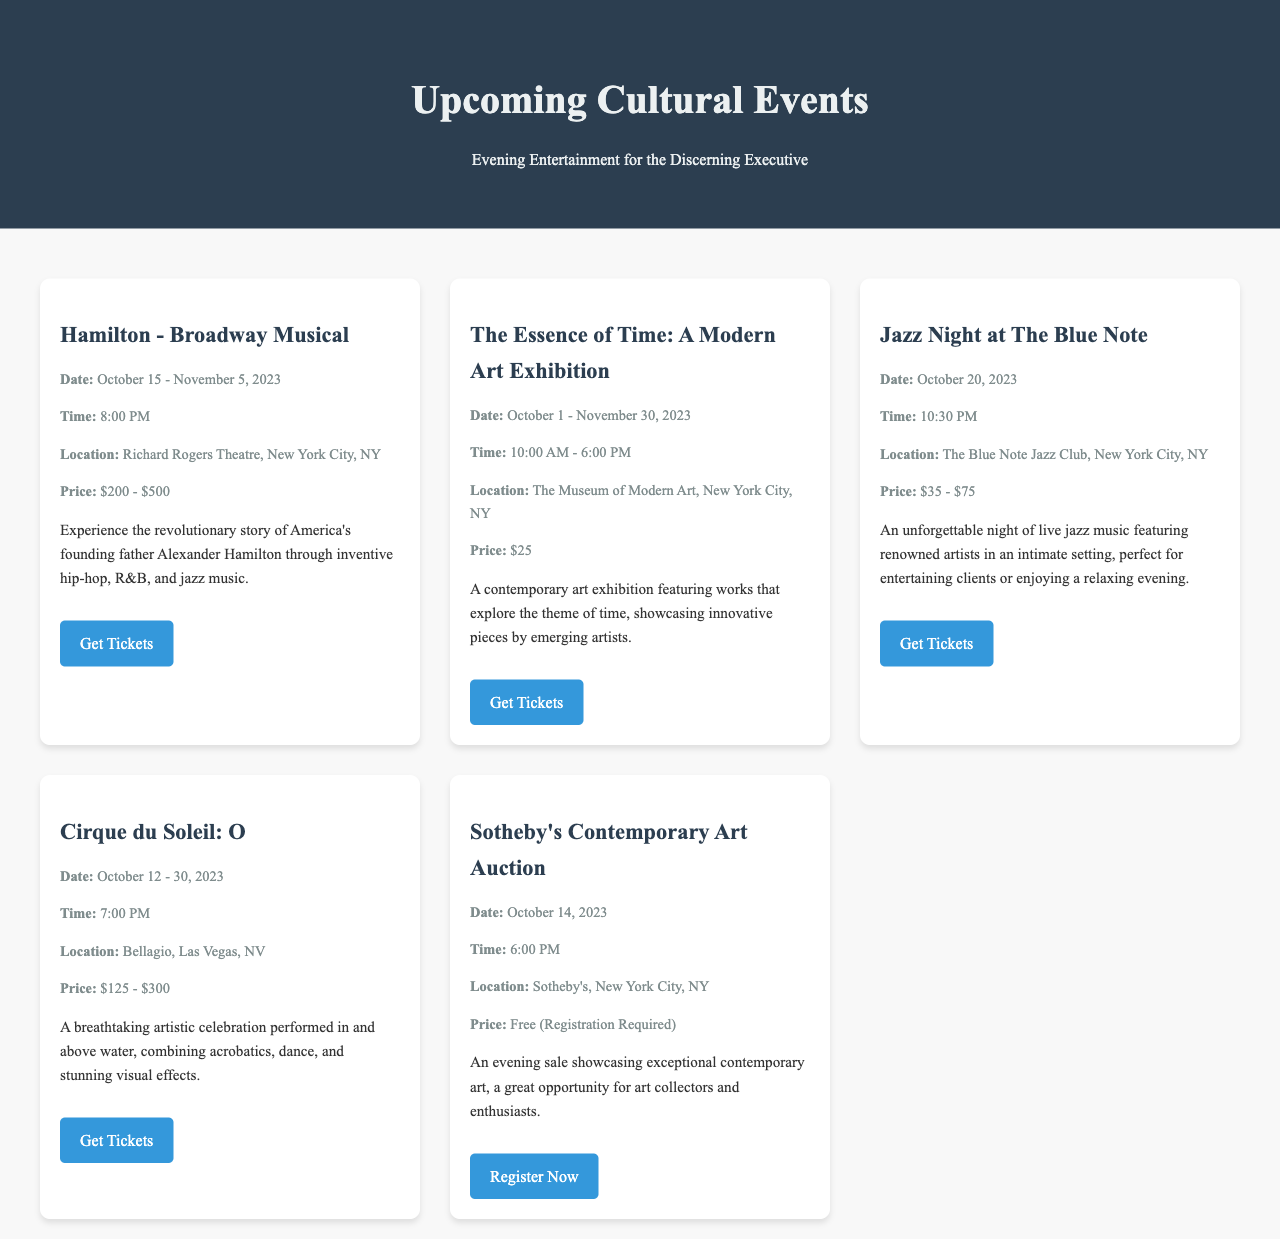What is the date range for the Hamilton musical? The date range for Hamilton is mentioned in the event details, which state October 15 to November 5, 2023.
Answer: October 15 - November 5, 2023 Where is the Essence of Time exhibition located? The document specifies the location of the Essence of Time exhibition, which is The Museum of Modern Art in New York City.
Answer: The Museum of Modern Art, New York City, NY What is the price range for Jazz Night at The Blue Note? The price range for Jazz Night at The Blue Note is clearly indicated, ranging from $35 to $75.
Answer: $35 - $75 When does Cirque du Soleil: O start? The start date for Cirque du Soleil: O is given in the event details as October 12, 2023.
Answer: October 12, 2023 What is required to attend Sotheby's Contemporary Art Auction? The requirements for attending Sotheby's auction, as stated, indicate that registration is required to enter.
Answer: Registration Required How many events feature live music? Upon reviewing the document, the events featuring live music are Jazz Night at The Blue Note and Cirque du Soleil: O, totaling two events.
Answer: 2 events What time does the Essence of Time exhibition open? The document specifies the opening time for the Essence of Time exhibition, which is 10:00 AM.
Answer: 10:00 AM Which event has the highest ticket price? By comparing the ticket prices listed, Hamilton has the highest ticket price, ranging from $200 to $500.
Answer: $200 - $500 